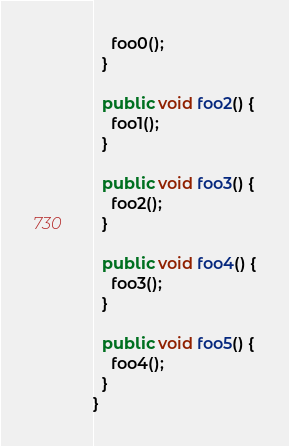Convert code to text. <code><loc_0><loc_0><loc_500><loc_500><_Java_>    foo0();
  }

  public void foo2() {
    foo1();
  }

  public void foo3() {
    foo2();
  }

  public void foo4() {
    foo3();
  }

  public void foo5() {
    foo4();
  }
}
</code> 